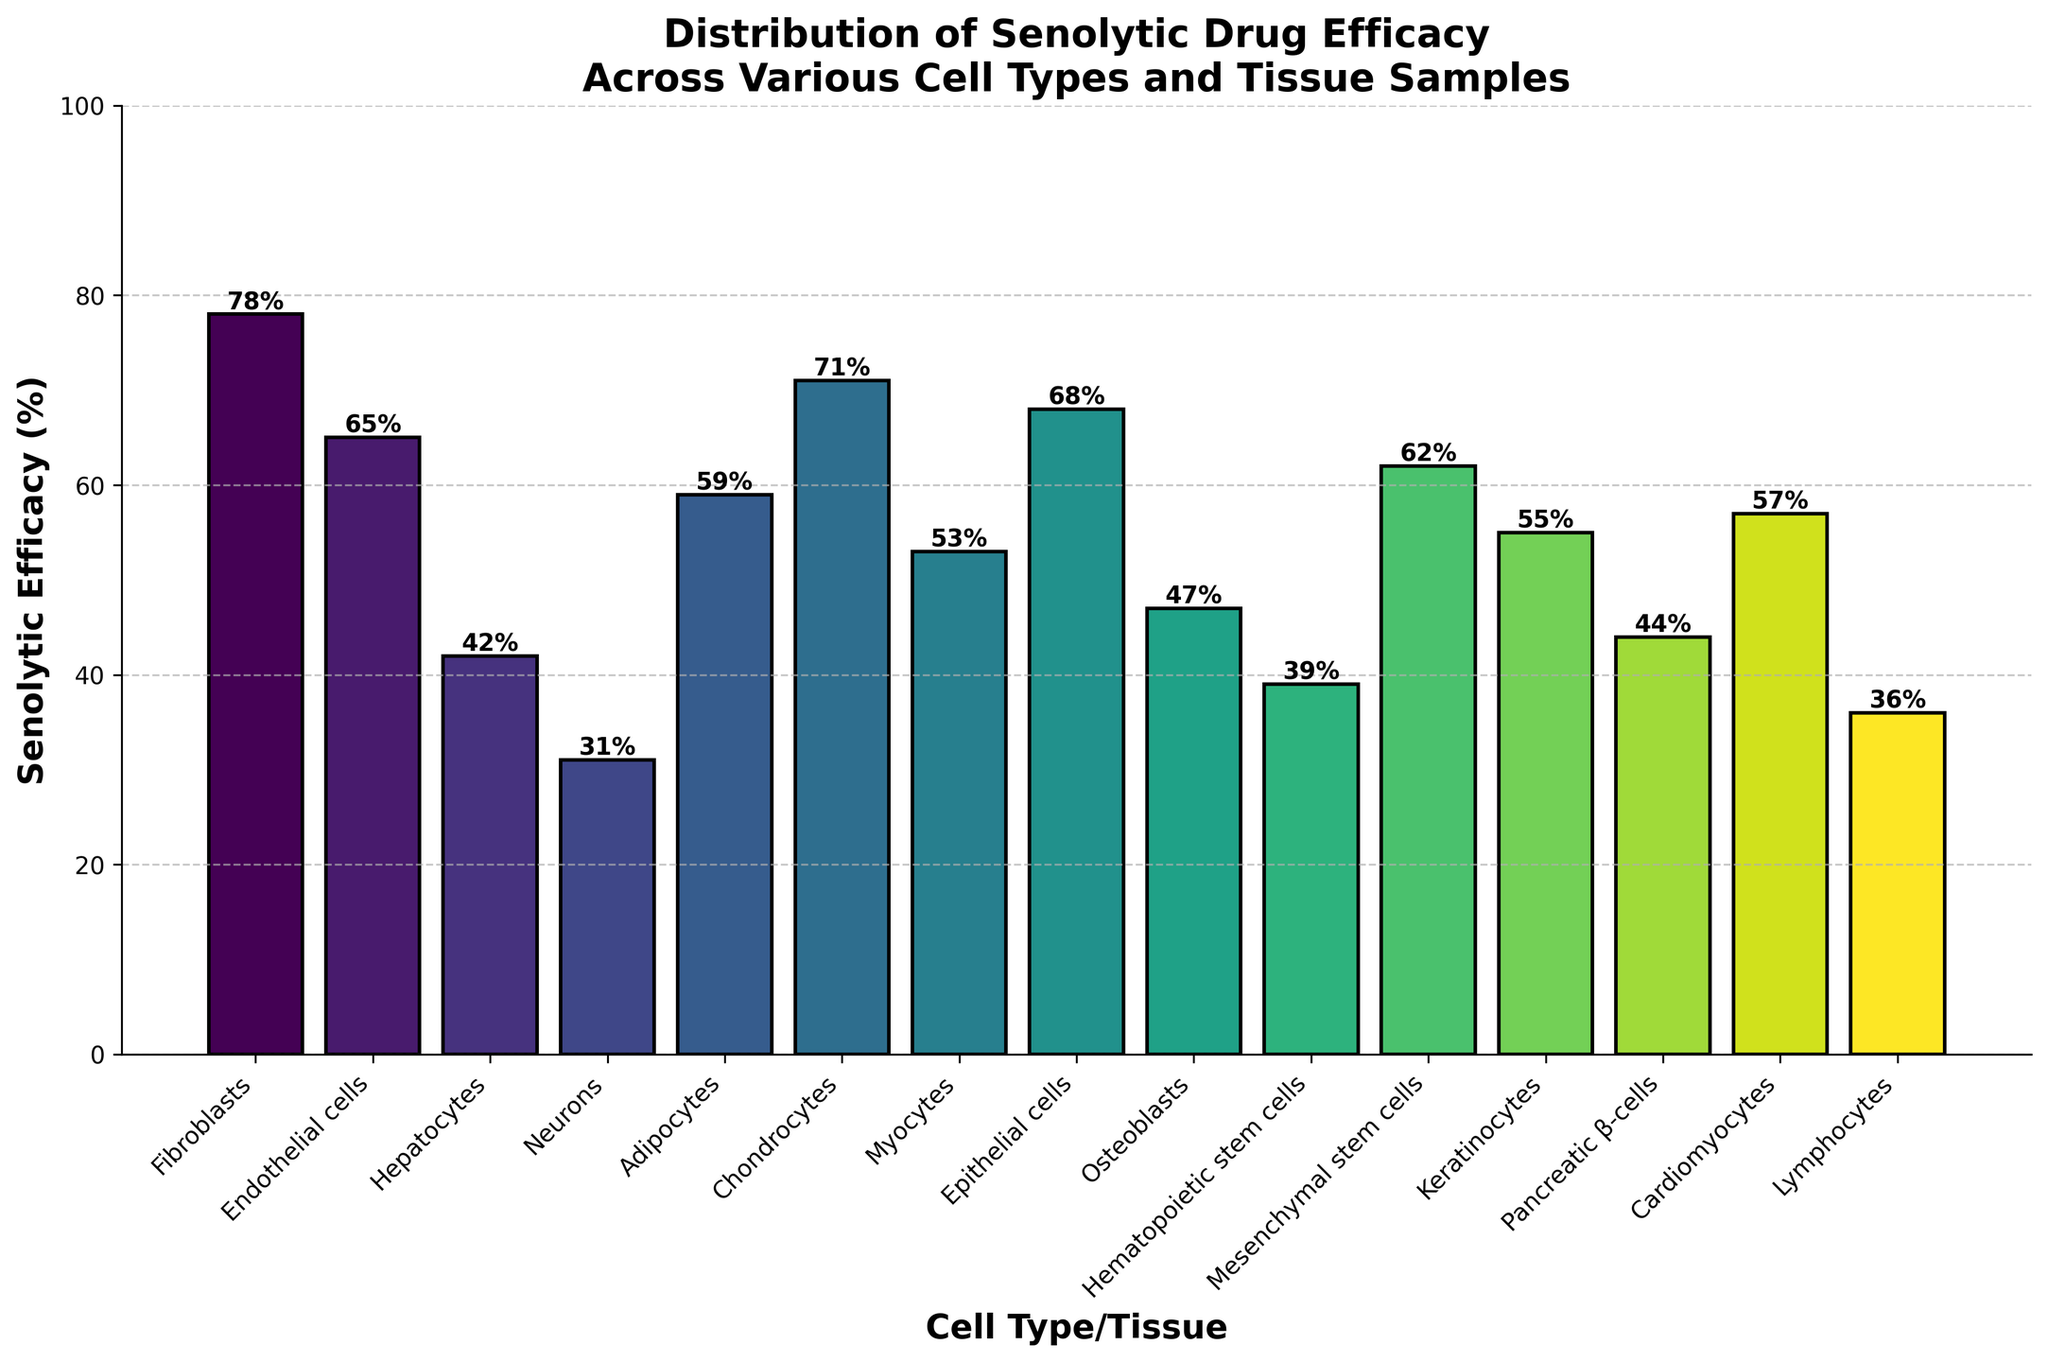What is the cell type/tissue with the highest senolytic efficacy? By inspecting the bar heights, the tallest bar represents the highest efficacy, which corresponds to Fibroblasts.
Answer: Fibroblasts Which cell type/tissue has the lowest senolytic efficacy? The shortest bar corresponds to the lowest efficacy, which is seen in Neurons.
Answer: Neurons What is the difference in senolytic efficacy between Endothelial cells and Adipocytes? The efficacy for Endothelial cells is 65%, and for Adipocytes, it's 59%. The difference is 65% - 59% = 6%.
Answer: 6% How many cell types/tissues have a senolytic efficacy greater than 60%? Bars taller than the 60% mark represent this. Counting these bars, we find Fibroblasts (78%), Endothelial cells (65%), Chondrocytes (71%), Epithelial cells (68%), and Mesenchymal stem cells (62%). There are 5 in total.
Answer: 5 Compare the senolytic efficacy of Epithelial cells and Myocytes. Which one is higher, and by how much? Epithelial cells have an efficacy of 68%, while Myocytes have 53%. Epithelial cells have a higher efficacy by 68% - 53% = 15%.
Answer: Epithelial cells by 15% What are the average senolytic efficacies of the three cell types/tissues with the highest efficacies? The highest efficacies are for Fibroblasts (78%), Chondrocytes (71%), and Epithelial cells (68%). The average is calculated as (78% + 71% + 68%) / 3 = 72.33%.
Answer: 72.33% Which cell type/tissue has a senolytic efficacy closest to 50%? Bars around the 50% mark include Myocytes (53%), Epithelial cells (47%), and Keratinocytes (55%). The closest to 50% is Osteoblasts with 47%.
Answer: Osteoblasts How much higher is the efficacy of Keratinocytes compared to Lymphocytes? Keratinocytes have an efficacy of 55%, and Lymphocytes have 36%. The difference is 55% - 36% = 19%.
Answer: 19% What is the sum of the senolytic efficacies of Fibroblasts, Endothelial cells, and Hepatocytes? Summing the efficacies: 78% (Fibroblasts) + 65% (Endothelial cells) + 42% (Hepatocytes) = 185%.
Answer: 185% What color transition is observed across the bars from the lowest to the highest efficacy? The bars change color from dark blue to lighter greenish-yellow, indicating an increasing gradient with efficacy.
Answer: Dark blue to greenish-yellow 